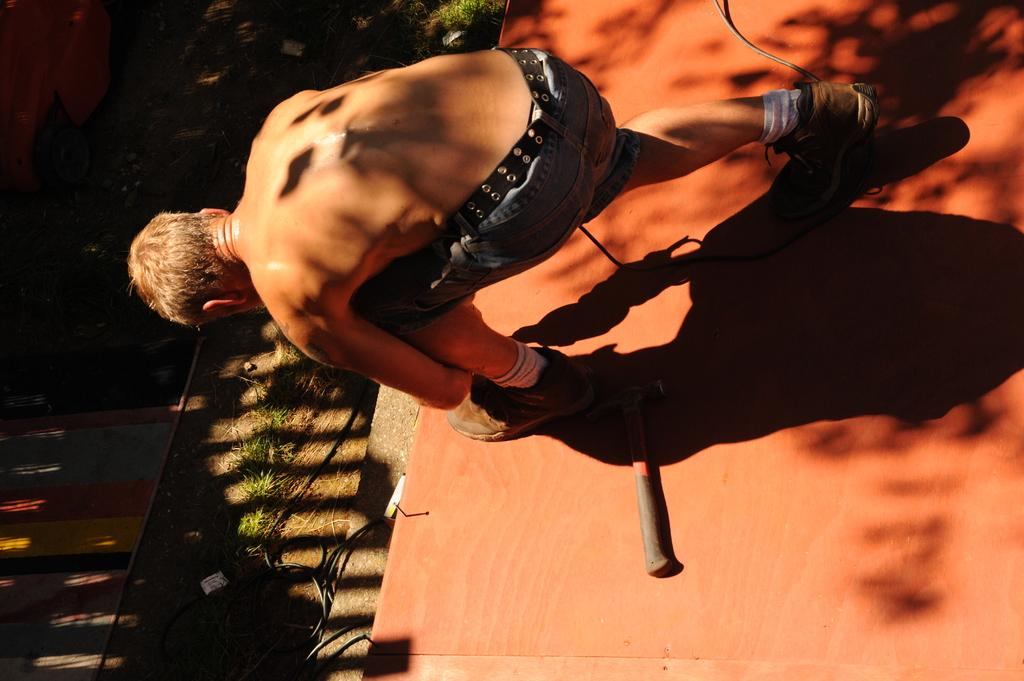What is the man in the image doing? The man is bending down and tying his shoelace. Can you describe the man's position in the image? The man is bending down. What object is visible behind the man? There is a hammer behind the man. What type of surface is the man standing on? There is grass on the ground in front of the man. What type of paste is the man using to attack the hammer in the image? There is no paste or attack present in the image; the man is simply tying his shoelace, and there is a hammer behind him. 